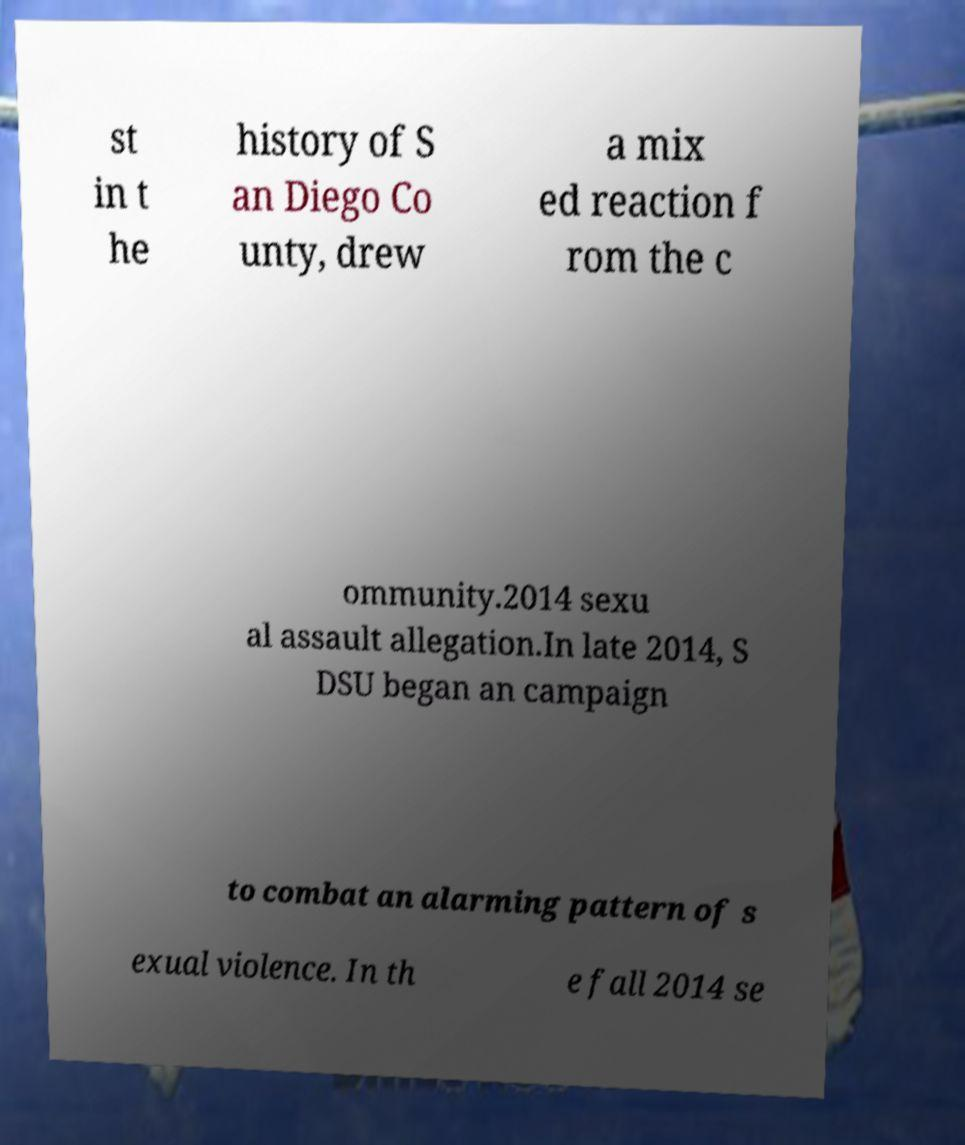For documentation purposes, I need the text within this image transcribed. Could you provide that? st in t he history of S an Diego Co unty, drew a mix ed reaction f rom the c ommunity.2014 sexu al assault allegation.In late 2014, S DSU began an campaign to combat an alarming pattern of s exual violence. In th e fall 2014 se 